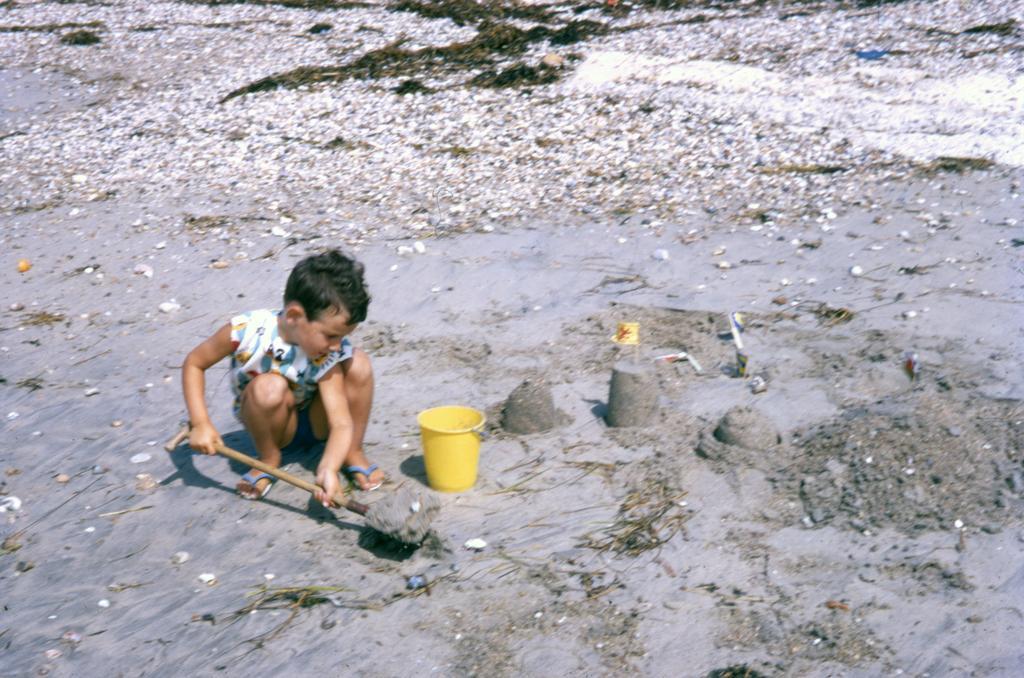In one or two sentences, can you explain what this image depicts? In the center of the image we can see one kid sitting and holding one object. In front of a kid, we can see one yellow bucket. In the background we can see waste papers, mud and a few other objects. 